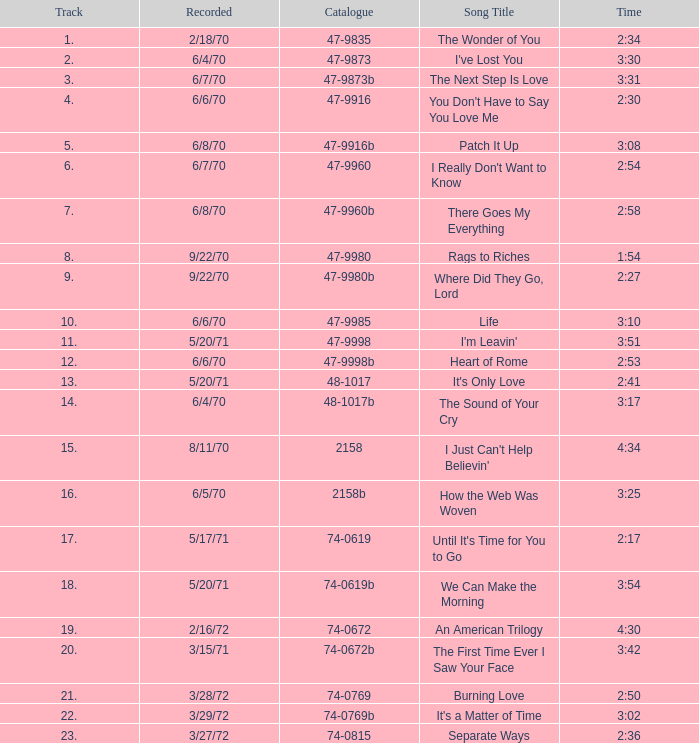What is Heart of Rome's catalogue number? 47-9998b. 